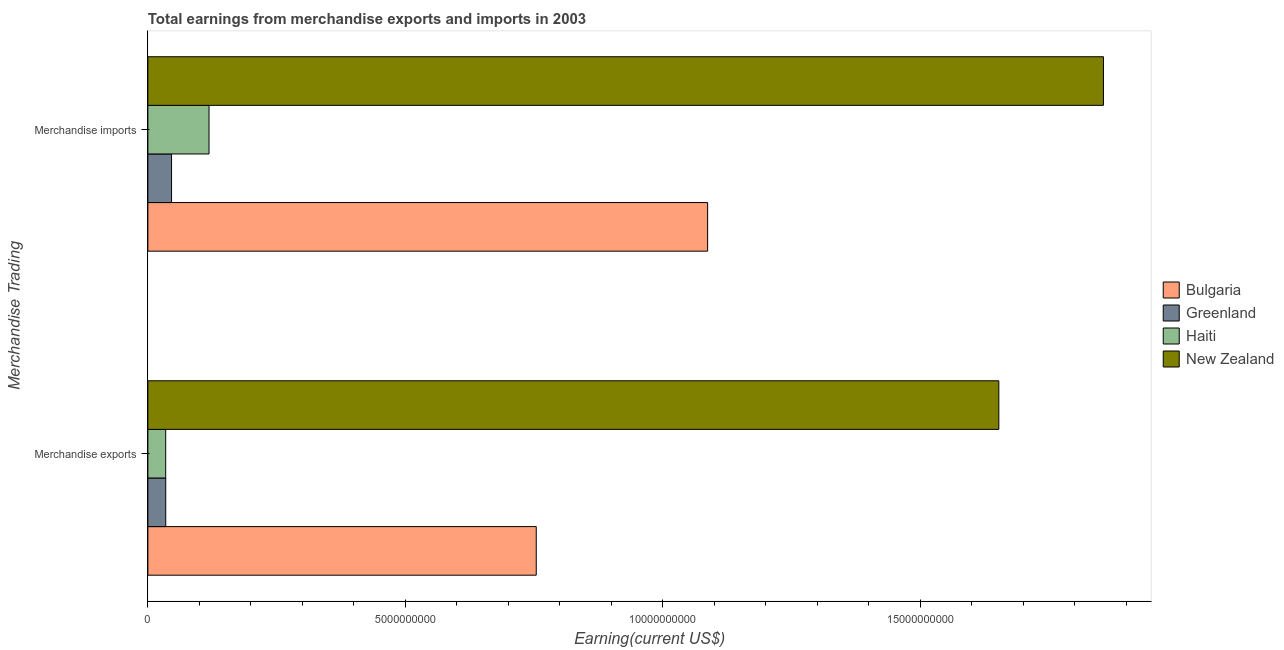How many different coloured bars are there?
Give a very brief answer. 4. How many bars are there on the 1st tick from the top?
Your answer should be compact. 4. What is the label of the 1st group of bars from the top?
Offer a terse response. Merchandise imports. What is the earnings from merchandise exports in Bulgaria?
Your response must be concise. 7.54e+09. Across all countries, what is the maximum earnings from merchandise imports?
Provide a succinct answer. 1.86e+1. Across all countries, what is the minimum earnings from merchandise exports?
Offer a terse response. 3.47e+08. In which country was the earnings from merchandise imports maximum?
Offer a very short reply. New Zealand. In which country was the earnings from merchandise exports minimum?
Your answer should be compact. Haiti. What is the total earnings from merchandise exports in the graph?
Provide a succinct answer. 2.48e+1. What is the difference between the earnings from merchandise imports in Haiti and that in Greenland?
Your response must be concise. 7.28e+08. What is the difference between the earnings from merchandise exports in New Zealand and the earnings from merchandise imports in Bulgaria?
Ensure brevity in your answer.  5.66e+09. What is the average earnings from merchandise imports per country?
Keep it short and to the point. 7.77e+09. What is the difference between the earnings from merchandise exports and earnings from merchandise imports in Bulgaria?
Offer a terse response. -3.33e+09. In how many countries, is the earnings from merchandise imports greater than 9000000000 US$?
Your answer should be compact. 2. What is the ratio of the earnings from merchandise imports in New Zealand to that in Bulgaria?
Ensure brevity in your answer.  1.71. What does the 3rd bar from the top in Merchandise exports represents?
Provide a succinct answer. Greenland. What does the 3rd bar from the bottom in Merchandise exports represents?
Keep it short and to the point. Haiti. How many countries are there in the graph?
Your answer should be very brief. 4. What is the difference between two consecutive major ticks on the X-axis?
Offer a terse response. 5.00e+09. Are the values on the major ticks of X-axis written in scientific E-notation?
Your response must be concise. No. Does the graph contain any zero values?
Keep it short and to the point. No. How are the legend labels stacked?
Make the answer very short. Vertical. What is the title of the graph?
Give a very brief answer. Total earnings from merchandise exports and imports in 2003. Does "Azerbaijan" appear as one of the legend labels in the graph?
Your answer should be compact. No. What is the label or title of the X-axis?
Provide a succinct answer. Earning(current US$). What is the label or title of the Y-axis?
Provide a succinct answer. Merchandise Trading. What is the Earning(current US$) of Bulgaria in Merchandise exports?
Provide a succinct answer. 7.54e+09. What is the Earning(current US$) in Greenland in Merchandise exports?
Ensure brevity in your answer.  3.47e+08. What is the Earning(current US$) of Haiti in Merchandise exports?
Give a very brief answer. 3.47e+08. What is the Earning(current US$) of New Zealand in Merchandise exports?
Offer a very short reply. 1.65e+1. What is the Earning(current US$) in Bulgaria in Merchandise imports?
Give a very brief answer. 1.09e+1. What is the Earning(current US$) in Greenland in Merchandise imports?
Give a very brief answer. 4.60e+08. What is the Earning(current US$) in Haiti in Merchandise imports?
Provide a short and direct response. 1.19e+09. What is the Earning(current US$) in New Zealand in Merchandise imports?
Your response must be concise. 1.86e+1. Across all Merchandise Trading, what is the maximum Earning(current US$) of Bulgaria?
Your answer should be compact. 1.09e+1. Across all Merchandise Trading, what is the maximum Earning(current US$) in Greenland?
Your answer should be compact. 4.60e+08. Across all Merchandise Trading, what is the maximum Earning(current US$) of Haiti?
Your response must be concise. 1.19e+09. Across all Merchandise Trading, what is the maximum Earning(current US$) of New Zealand?
Provide a succinct answer. 1.86e+1. Across all Merchandise Trading, what is the minimum Earning(current US$) in Bulgaria?
Your answer should be very brief. 7.54e+09. Across all Merchandise Trading, what is the minimum Earning(current US$) of Greenland?
Provide a short and direct response. 3.47e+08. Across all Merchandise Trading, what is the minimum Earning(current US$) in Haiti?
Make the answer very short. 3.47e+08. Across all Merchandise Trading, what is the minimum Earning(current US$) in New Zealand?
Ensure brevity in your answer.  1.65e+1. What is the total Earning(current US$) in Bulgaria in the graph?
Keep it short and to the point. 1.84e+1. What is the total Earning(current US$) in Greenland in the graph?
Provide a short and direct response. 8.07e+08. What is the total Earning(current US$) in Haiti in the graph?
Your answer should be very brief. 1.53e+09. What is the total Earning(current US$) in New Zealand in the graph?
Your response must be concise. 3.51e+1. What is the difference between the Earning(current US$) of Bulgaria in Merchandise exports and that in Merchandise imports?
Your answer should be compact. -3.33e+09. What is the difference between the Earning(current US$) of Greenland in Merchandise exports and that in Merchandise imports?
Give a very brief answer. -1.13e+08. What is the difference between the Earning(current US$) of Haiti in Merchandise exports and that in Merchandise imports?
Provide a short and direct response. -8.41e+08. What is the difference between the Earning(current US$) of New Zealand in Merchandise exports and that in Merchandise imports?
Your response must be concise. -2.03e+09. What is the difference between the Earning(current US$) in Bulgaria in Merchandise exports and the Earning(current US$) in Greenland in Merchandise imports?
Your answer should be compact. 7.08e+09. What is the difference between the Earning(current US$) in Bulgaria in Merchandise exports and the Earning(current US$) in Haiti in Merchandise imports?
Make the answer very short. 6.36e+09. What is the difference between the Earning(current US$) of Bulgaria in Merchandise exports and the Earning(current US$) of New Zealand in Merchandise imports?
Your answer should be compact. -1.10e+1. What is the difference between the Earning(current US$) of Greenland in Merchandise exports and the Earning(current US$) of Haiti in Merchandise imports?
Your answer should be very brief. -8.41e+08. What is the difference between the Earning(current US$) in Greenland in Merchandise exports and the Earning(current US$) in New Zealand in Merchandise imports?
Your answer should be very brief. -1.82e+1. What is the difference between the Earning(current US$) in Haiti in Merchandise exports and the Earning(current US$) in New Zealand in Merchandise imports?
Provide a succinct answer. -1.82e+1. What is the average Earning(current US$) in Bulgaria per Merchandise Trading?
Provide a short and direct response. 9.21e+09. What is the average Earning(current US$) of Greenland per Merchandise Trading?
Provide a succinct answer. 4.04e+08. What is the average Earning(current US$) of Haiti per Merchandise Trading?
Provide a short and direct response. 7.67e+08. What is the average Earning(current US$) of New Zealand per Merchandise Trading?
Your answer should be very brief. 1.75e+1. What is the difference between the Earning(current US$) of Bulgaria and Earning(current US$) of Greenland in Merchandise exports?
Your response must be concise. 7.20e+09. What is the difference between the Earning(current US$) of Bulgaria and Earning(current US$) of Haiti in Merchandise exports?
Make the answer very short. 7.20e+09. What is the difference between the Earning(current US$) of Bulgaria and Earning(current US$) of New Zealand in Merchandise exports?
Make the answer very short. -8.98e+09. What is the difference between the Earning(current US$) of Greenland and Earning(current US$) of Haiti in Merchandise exports?
Make the answer very short. 4.50e+05. What is the difference between the Earning(current US$) in Greenland and Earning(current US$) in New Zealand in Merchandise exports?
Your response must be concise. -1.62e+1. What is the difference between the Earning(current US$) of Haiti and Earning(current US$) of New Zealand in Merchandise exports?
Offer a terse response. -1.62e+1. What is the difference between the Earning(current US$) of Bulgaria and Earning(current US$) of Greenland in Merchandise imports?
Provide a short and direct response. 1.04e+1. What is the difference between the Earning(current US$) in Bulgaria and Earning(current US$) in Haiti in Merchandise imports?
Your answer should be compact. 9.68e+09. What is the difference between the Earning(current US$) in Bulgaria and Earning(current US$) in New Zealand in Merchandise imports?
Keep it short and to the point. -7.69e+09. What is the difference between the Earning(current US$) of Greenland and Earning(current US$) of Haiti in Merchandise imports?
Make the answer very short. -7.28e+08. What is the difference between the Earning(current US$) in Greenland and Earning(current US$) in New Zealand in Merchandise imports?
Keep it short and to the point. -1.81e+1. What is the difference between the Earning(current US$) in Haiti and Earning(current US$) in New Zealand in Merchandise imports?
Make the answer very short. -1.74e+1. What is the ratio of the Earning(current US$) in Bulgaria in Merchandise exports to that in Merchandise imports?
Provide a short and direct response. 0.69. What is the ratio of the Earning(current US$) in Greenland in Merchandise exports to that in Merchandise imports?
Provide a succinct answer. 0.75. What is the ratio of the Earning(current US$) in Haiti in Merchandise exports to that in Merchandise imports?
Provide a short and direct response. 0.29. What is the ratio of the Earning(current US$) of New Zealand in Merchandise exports to that in Merchandise imports?
Make the answer very short. 0.89. What is the difference between the highest and the second highest Earning(current US$) in Bulgaria?
Offer a terse response. 3.33e+09. What is the difference between the highest and the second highest Earning(current US$) in Greenland?
Your answer should be very brief. 1.13e+08. What is the difference between the highest and the second highest Earning(current US$) in Haiti?
Your answer should be very brief. 8.41e+08. What is the difference between the highest and the second highest Earning(current US$) of New Zealand?
Offer a very short reply. 2.03e+09. What is the difference between the highest and the lowest Earning(current US$) in Bulgaria?
Ensure brevity in your answer.  3.33e+09. What is the difference between the highest and the lowest Earning(current US$) of Greenland?
Your answer should be very brief. 1.13e+08. What is the difference between the highest and the lowest Earning(current US$) in Haiti?
Offer a terse response. 8.41e+08. What is the difference between the highest and the lowest Earning(current US$) of New Zealand?
Offer a terse response. 2.03e+09. 